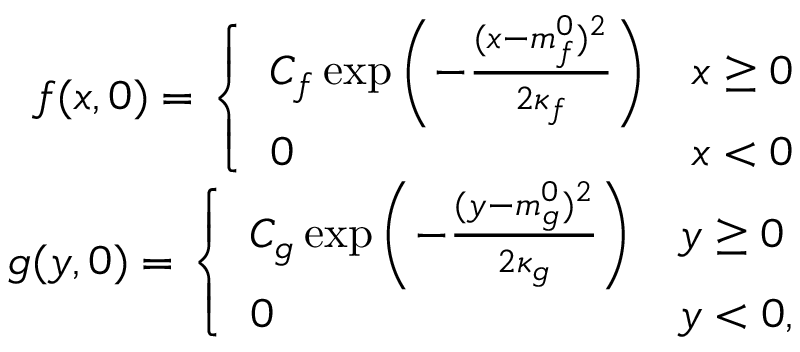<formula> <loc_0><loc_0><loc_500><loc_500>\begin{array} { r } { f ( x , 0 ) = \left \{ \begin{array} { l l } { C _ { f } \exp \left ( - \frac { ( x - m _ { f } ^ { 0 } ) ^ { 2 } } { 2 \kappa _ { f } } \right ) } & { x \geq 0 } \\ { 0 } & { x < 0 } \end{array} } \\ { g ( y , 0 ) = \left \{ \begin{array} { l l } { C _ { g } \exp \left ( - \frac { ( y - m _ { g } ^ { 0 } ) ^ { 2 } } { 2 \kappa _ { g } } \right ) } & { y \geq 0 } \\ { 0 } & { y < 0 , } \end{array} } \end{array}</formula> 